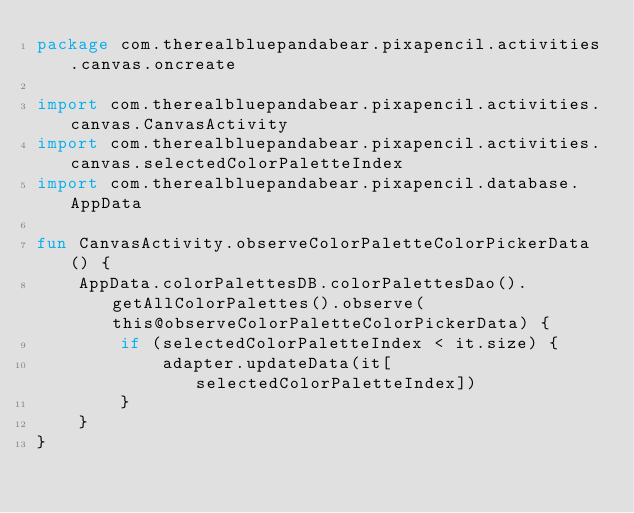<code> <loc_0><loc_0><loc_500><loc_500><_Kotlin_>package com.therealbluepandabear.pixapencil.activities.canvas.oncreate

import com.therealbluepandabear.pixapencil.activities.canvas.CanvasActivity
import com.therealbluepandabear.pixapencil.activities.canvas.selectedColorPaletteIndex
import com.therealbluepandabear.pixapencil.database.AppData

fun CanvasActivity.observeColorPaletteColorPickerData() {
    AppData.colorPalettesDB.colorPalettesDao().getAllColorPalettes().observe(this@observeColorPaletteColorPickerData) {
        if (selectedColorPaletteIndex < it.size) {
            adapter.updateData(it[selectedColorPaletteIndex])
        }
    }
}
 </code> 